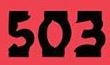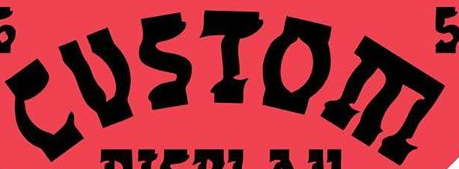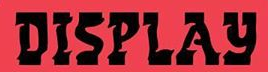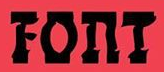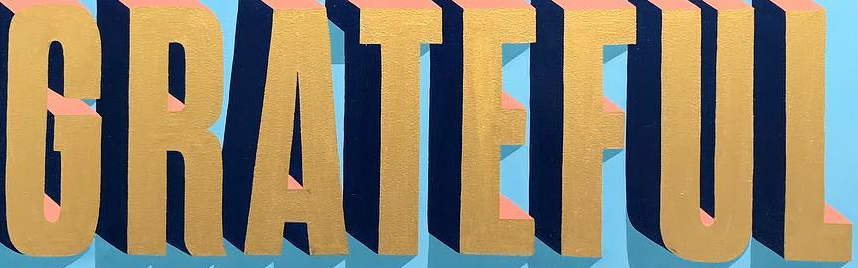What text appears in these images from left to right, separated by a semicolon? 503; CUSIOE; DISPLAY; FOnT; GRATEFUL 